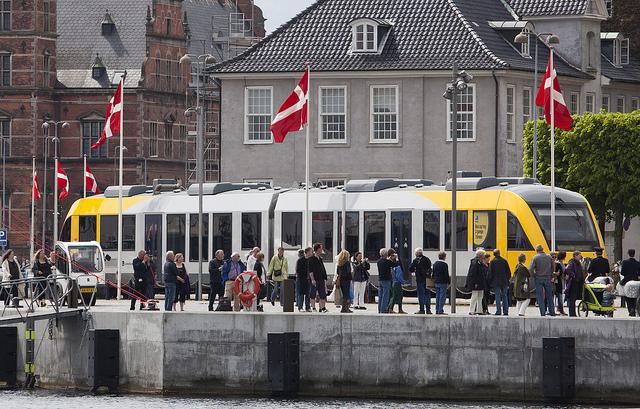How many red and white flags are there?
Answer briefly. 6. Are there any children in this photo?
Answer briefly. Yes. Are all these people waiting to cross the street?
Be succinct. No. Is this a photo of an American city?
Quick response, please. No. What color are the wheels on the carriage?
Be succinct. Black. What country is it?
Be succinct. Denmark. 